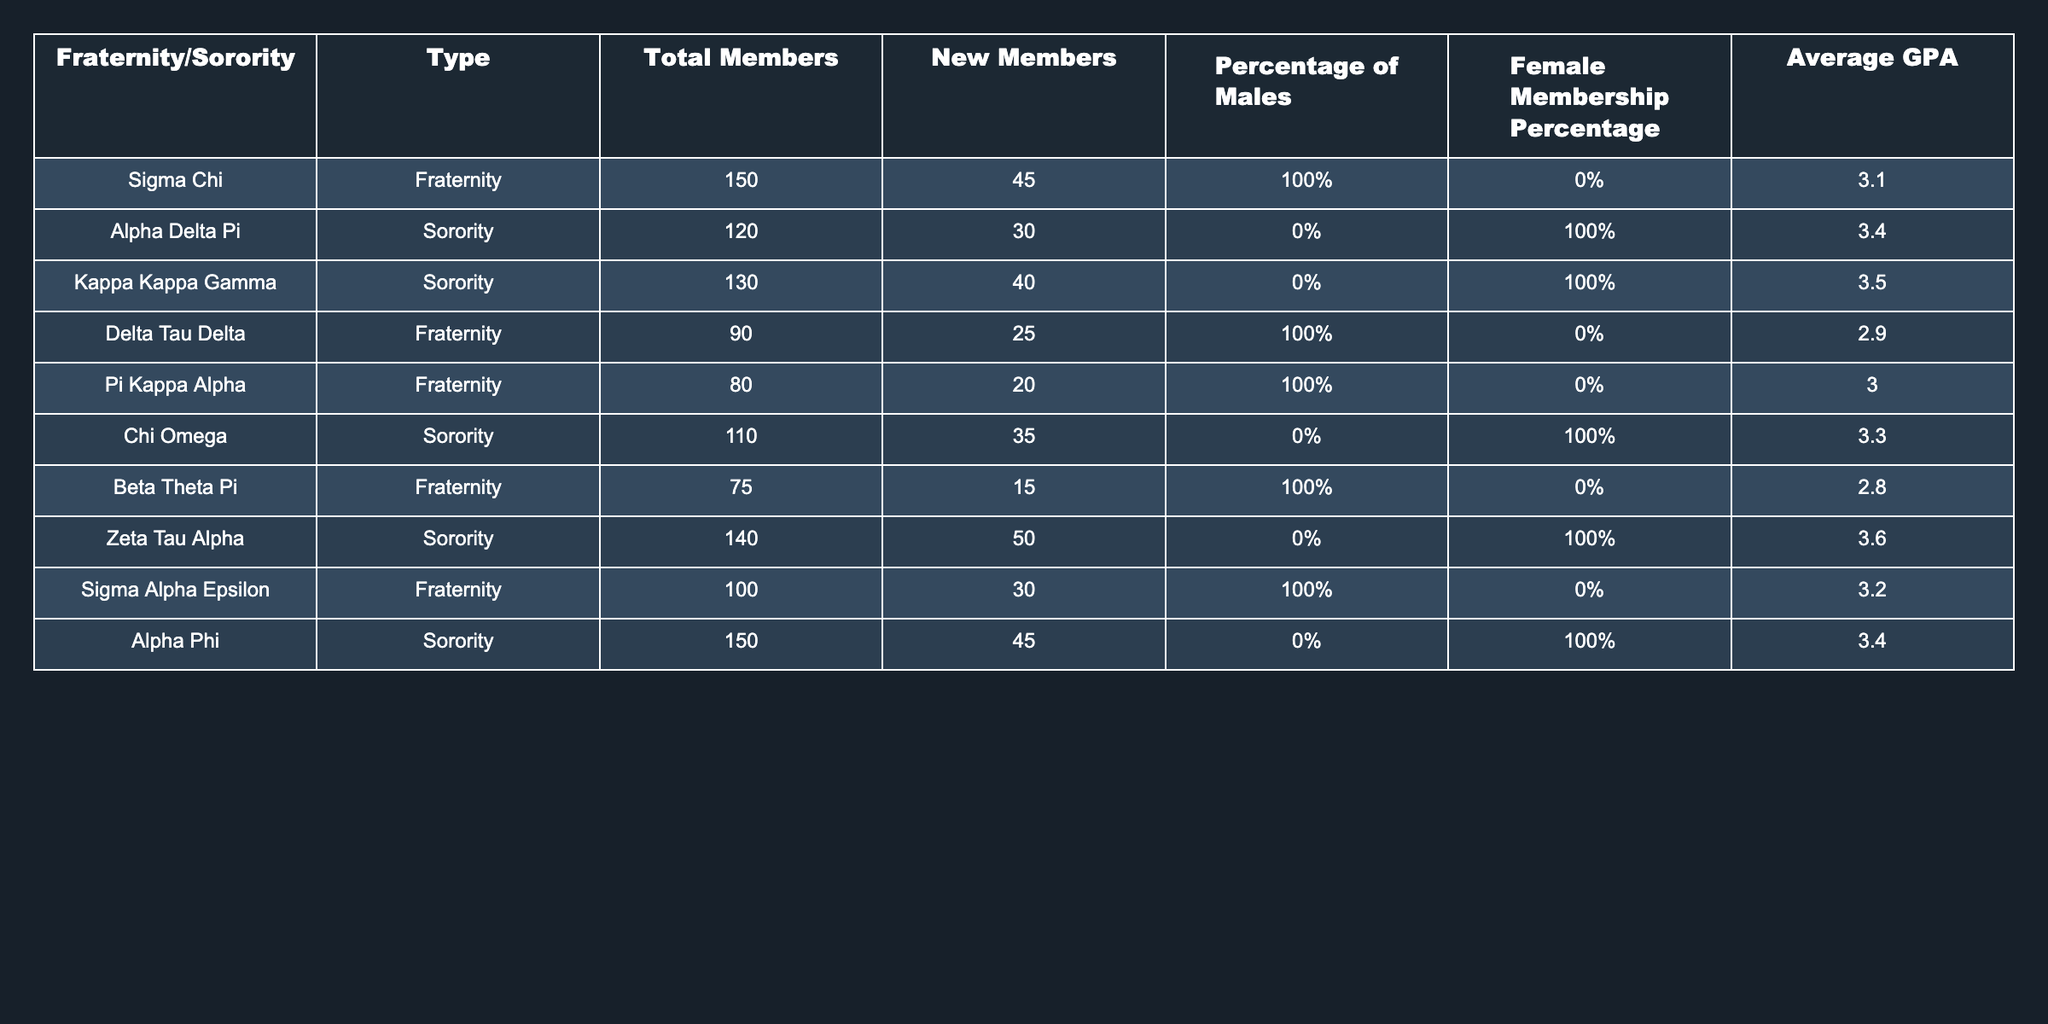What is the total number of members in Chi Omega? From the table, the "Total Members" count for Chi Omega is given directly as 110.
Answer: 110 What is the average GPA of the sororities listed? To find the average GPA of the sororities, we add the GPAs: 3.4 (Alpha Delta Pi) + 3.5 (Kappa Kappa Gamma) + 3.3 (Chi Omega) + 3.6 (Zeta Tau Alpha) + 3.4 (Alpha Phi) = 17.2. There are 5 sororities, so the average GPA is 17.2 / 5 = 3.44.
Answer: 3.44 Which fraternity has the lowest GPA? By looking at the "Average GPA" column for fraternities, we note the values: 3.1 (Sigma Chi), 2.9 (Delta Tau Delta), 3.0 (Pi Kappa Alpha), 2.8 (Beta Theta Pi), and 3.2 (Sigma Alpha Epsilon). The lowest GPA is 2.8 from Beta Theta Pi.
Answer: Beta Theta Pi Is there any fraternity with female membership? The table indicates that all fraternities have a female membership percentage of 0%, confirming there are no female members in any fraternity.
Answer: No What is the difference in total members between the largest sorority and the largest fraternity? The largest sorority, Alpha Phi, has 150 members, while the largest fraternity, Sigma Chi, also has 150 members. Thus, the difference is 150 - 150 = 0.
Answer: 0 How many new members did Zeta Tau Alpha gain? According to the table, Zeta Tau Alpha gained 50 new members as specified in the "New Members" column.
Answer: 50 Which fraternity has the highest percentage of males? From the table, all fraternities have a percentage of males listed as 100%, which is the highest possible percentage.
Answer: All fraternities What is the overall average GPA of all listed organizations? First, we sum the average GPAs: 3.1 (Sigma Chi) + 3.4 (Alpha Delta Pi) + 3.5 (Kappa Kappa Gamma) + 2.9 (Delta Tau Delta) + 3.0 (Pi Kappa Alpha) + 3.3 (Chi Omega) + 2.8 (Beta Theta Pi) + 3.6 (Zeta Tau Alpha) + 3.2 (Sigma Alpha Epsilon) + 3.4 (Alpha Phi) = 32.8. There are 10 organizations in total, so the average GPA is 32.8 / 10 = 3.28.
Answer: 3.28 How many members are in all of the sororities combined? The total memberships for sororities are: 120 (Alpha Delta Pi) + 130 (Kappa Kappa Gamma) + 110 (Chi Omega) + 140 (Zeta Tau Alpha) + 150 (Alpha Phi) = 750.
Answer: 750 Is the percentage of males higher in Pi Kappa Alpha or Delta Tau Delta? Both Pi Kappa Alpha and Delta Tau Delta have a male percentage of 100%, meaning there is no difference.
Answer: No difference 